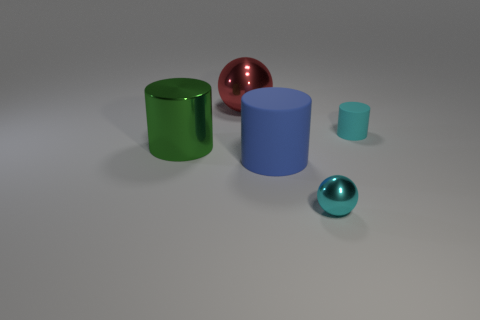There is another object that is the same color as the small metal thing; what is its size?
Give a very brief answer. Small. What material is the ball that is in front of the large red metallic object left of the small metallic sphere?
Provide a short and direct response. Metal. How many big balls are the same color as the metallic cylinder?
Your answer should be very brief. 0. What size is the blue cylinder that is made of the same material as the small cyan cylinder?
Keep it short and to the point. Large. There is a big red metal thing left of the small cyan ball; what is its shape?
Ensure brevity in your answer.  Sphere. There is another green thing that is the same shape as the tiny rubber object; what size is it?
Your answer should be compact. Large. How many cyan cylinders are left of the big metal ball that is behind the shiny ball that is to the right of the big red sphere?
Your response must be concise. 0. Are there an equal number of big red shiny objects in front of the blue matte cylinder and tiny purple rubber cubes?
Ensure brevity in your answer.  Yes. How many cylinders are small shiny objects or matte objects?
Keep it short and to the point. 2. Does the big shiny ball have the same color as the metal cylinder?
Provide a succinct answer. No. 